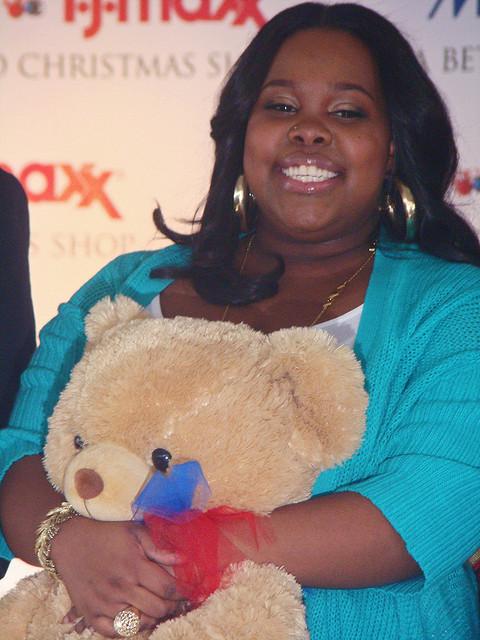What colors are in the scarf on the bear's neck?
Keep it brief. Red and blue. What company is posted behind woman's?
Be succinct. Tj maxx. Does this shirt need to be washed?
Answer briefly. No. What material is this girl's jewelry made of?
Write a very short answer. Gold. 